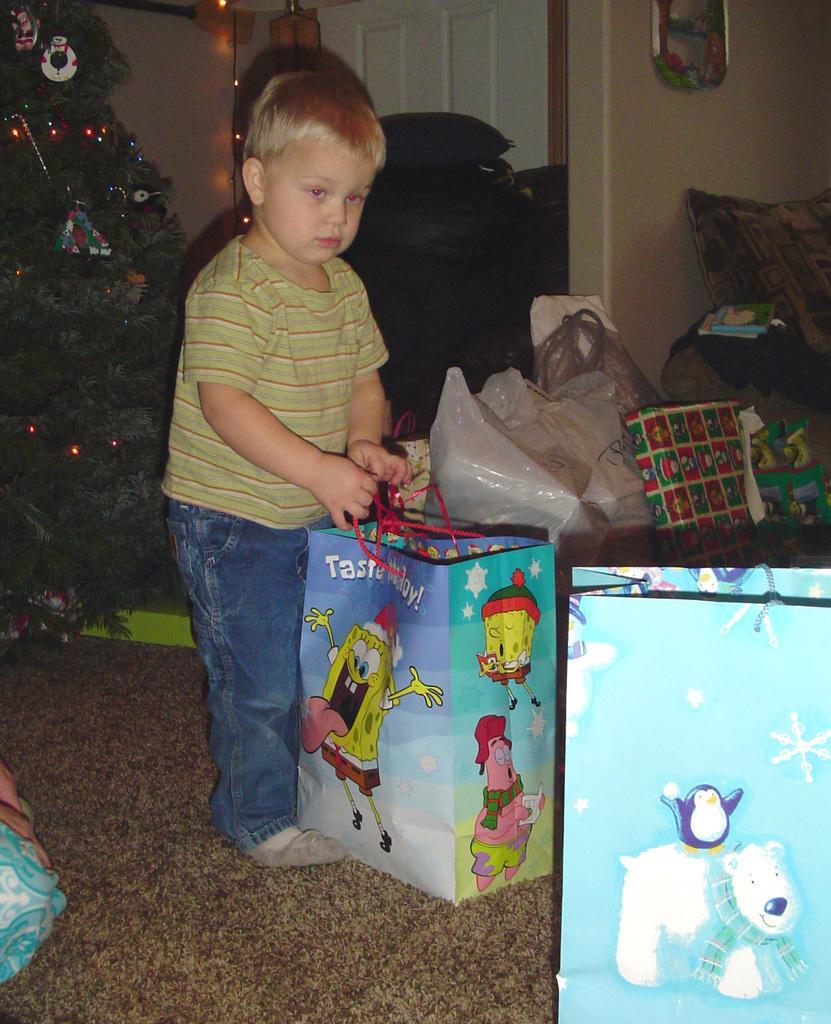How would you summarize this image in a sentence or two? In this picture I can observe a boy standing on the floor. On the left side I can observe Christmas tree. The boy is holding blue color cover in his hand. I can observe some covers on the right side. In the background there is a wall. 